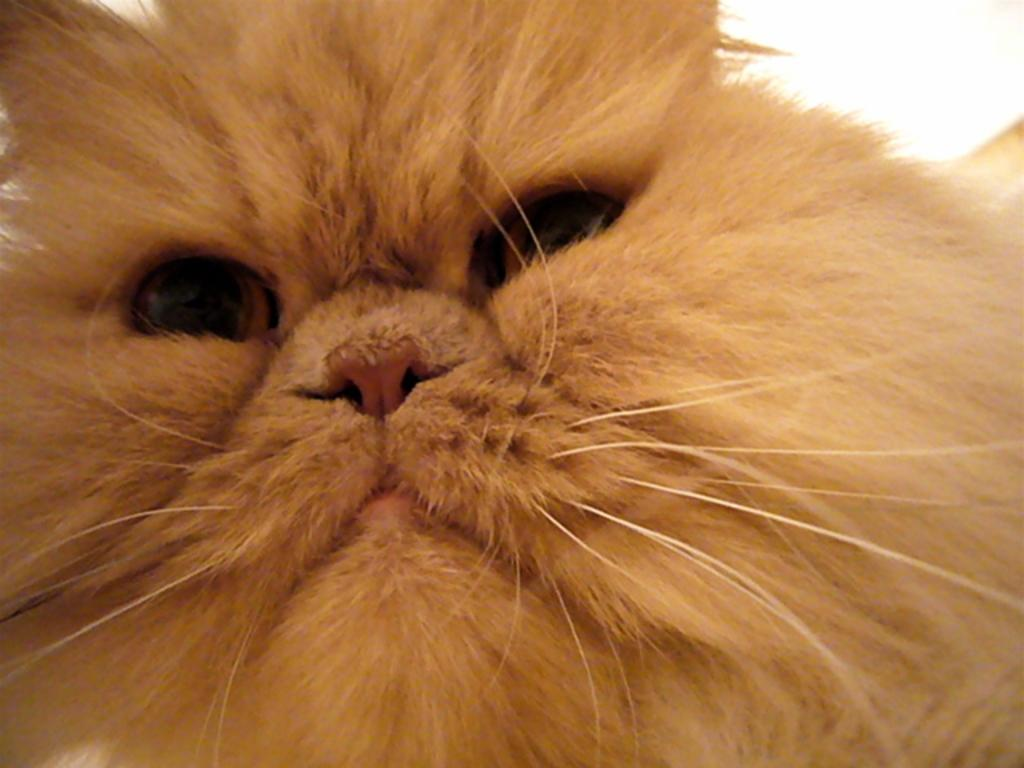What type of animal is in the image? There is a cat in the image. Can you describe the part of the cat that is visible in the image? The image shows the face of the cat. What type of breakfast is the cat eating in the image? There is no breakfast present in the image; it only shows the face of the cat. How many chairs are visible in the image? There are no chairs present in the image; it only shows the face of the cat. 